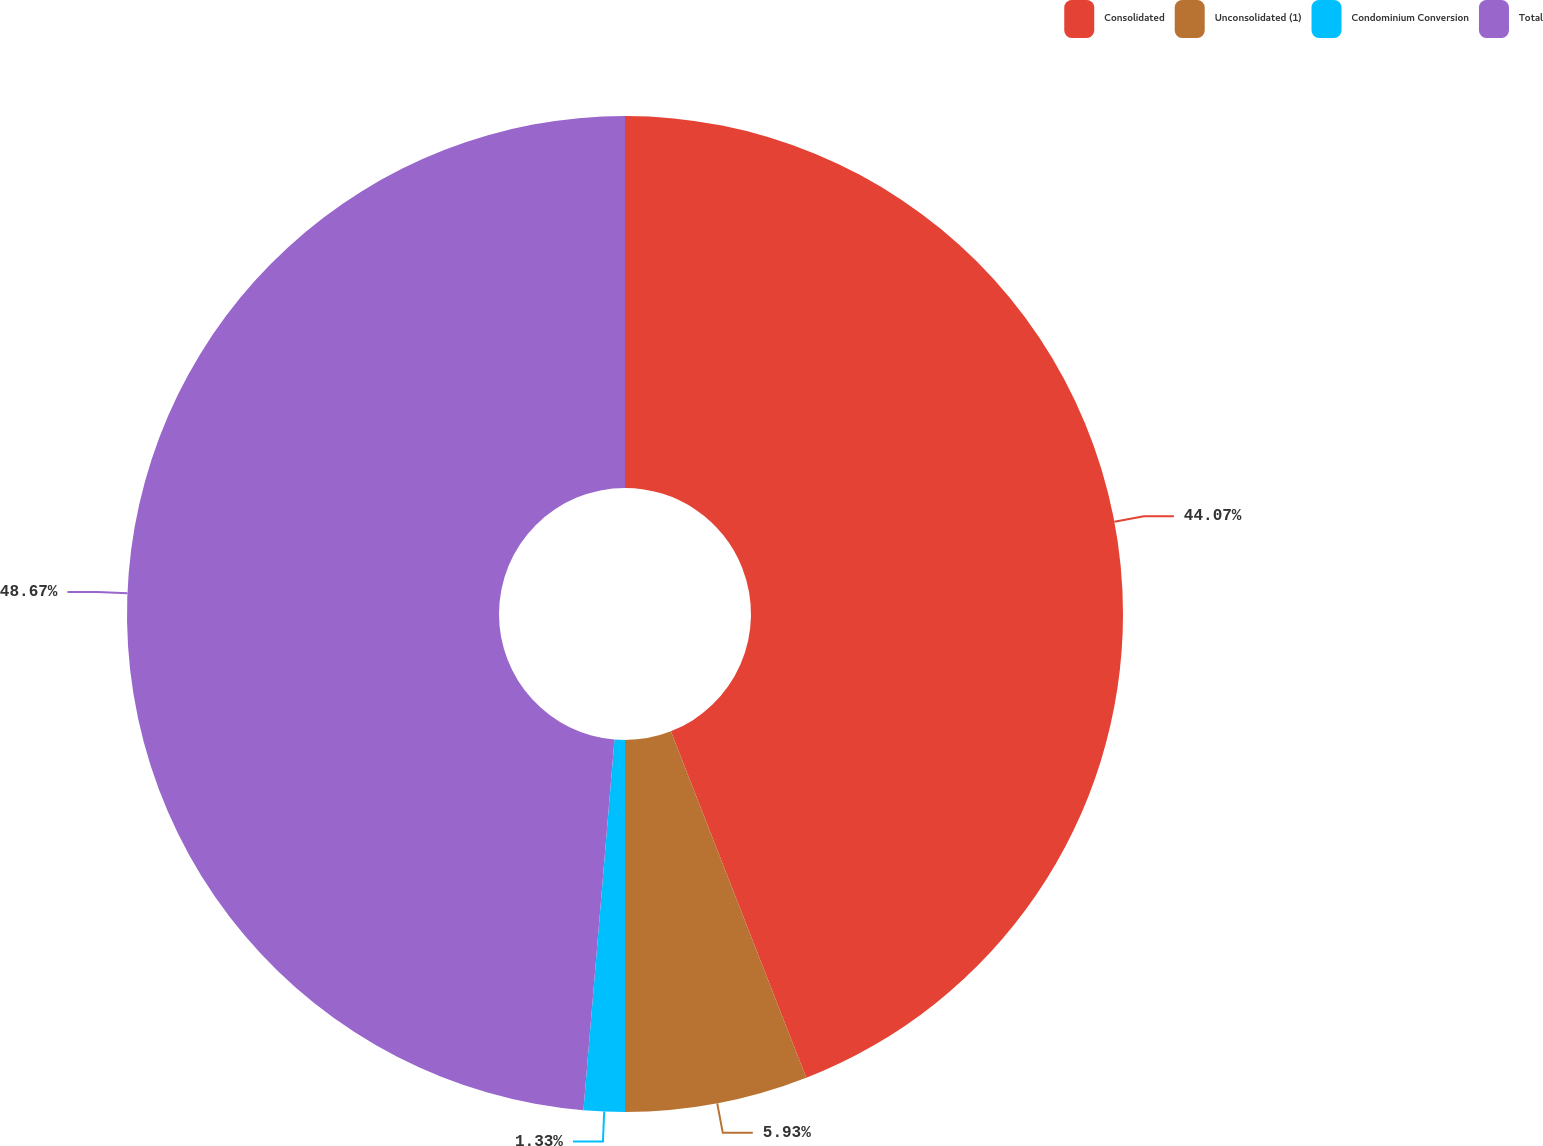Convert chart to OTSL. <chart><loc_0><loc_0><loc_500><loc_500><pie_chart><fcel>Consolidated<fcel>Unconsolidated (1)<fcel>Condominium Conversion<fcel>Total<nl><fcel>44.07%<fcel>5.93%<fcel>1.33%<fcel>48.67%<nl></chart> 